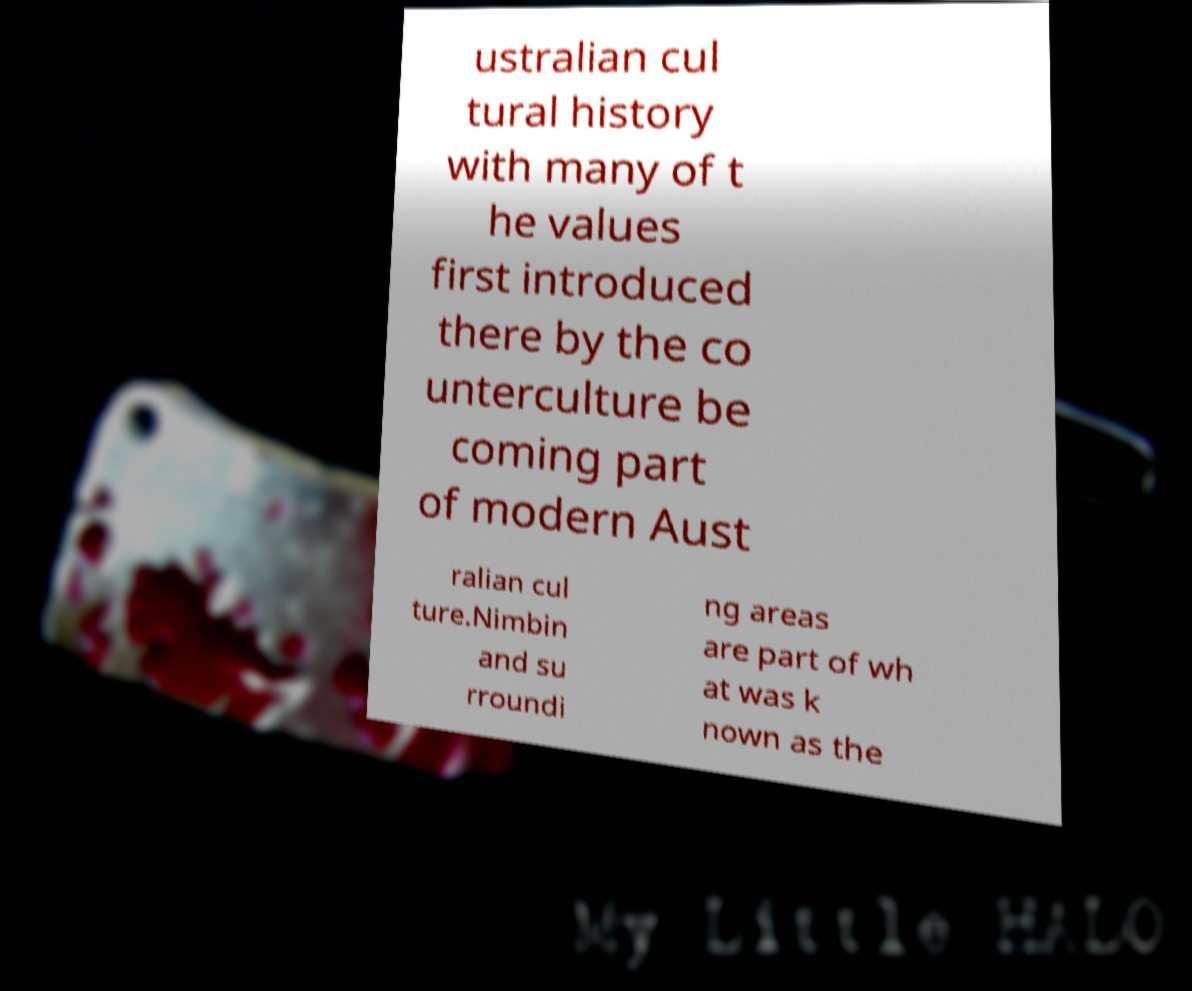Please read and relay the text visible in this image. What does it say? ustralian cul tural history with many of t he values first introduced there by the co unterculture be coming part of modern Aust ralian cul ture.Nimbin and su rroundi ng areas are part of wh at was k nown as the 